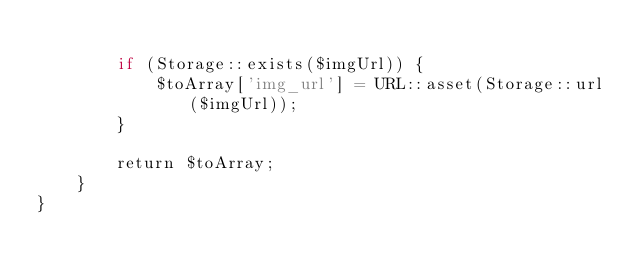Convert code to text. <code><loc_0><loc_0><loc_500><loc_500><_PHP_>        
        if (Storage::exists($imgUrl)) {
            $toArray['img_url'] = URL::asset(Storage::url($imgUrl));
        }
        
        return $toArray;
    }
}
</code> 